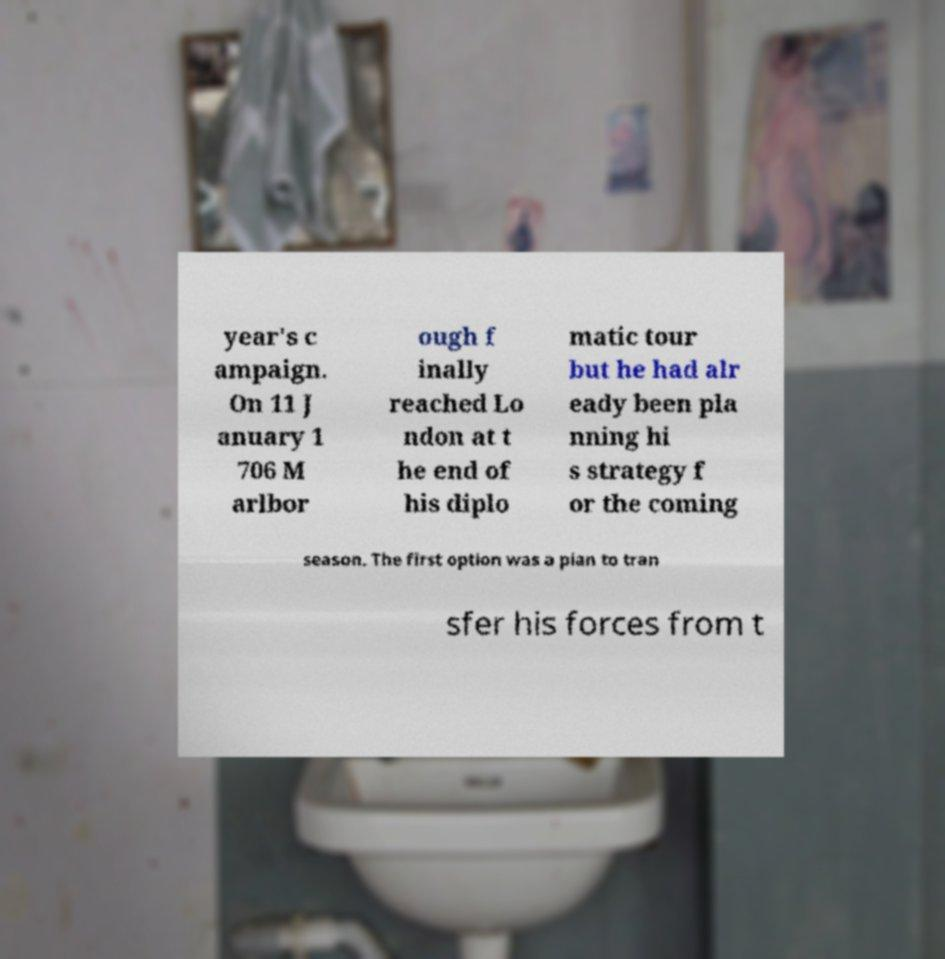For documentation purposes, I need the text within this image transcribed. Could you provide that? year's c ampaign. On 11 J anuary 1 706 M arlbor ough f inally reached Lo ndon at t he end of his diplo matic tour but he had alr eady been pla nning hi s strategy f or the coming season. The first option was a plan to tran sfer his forces from t 